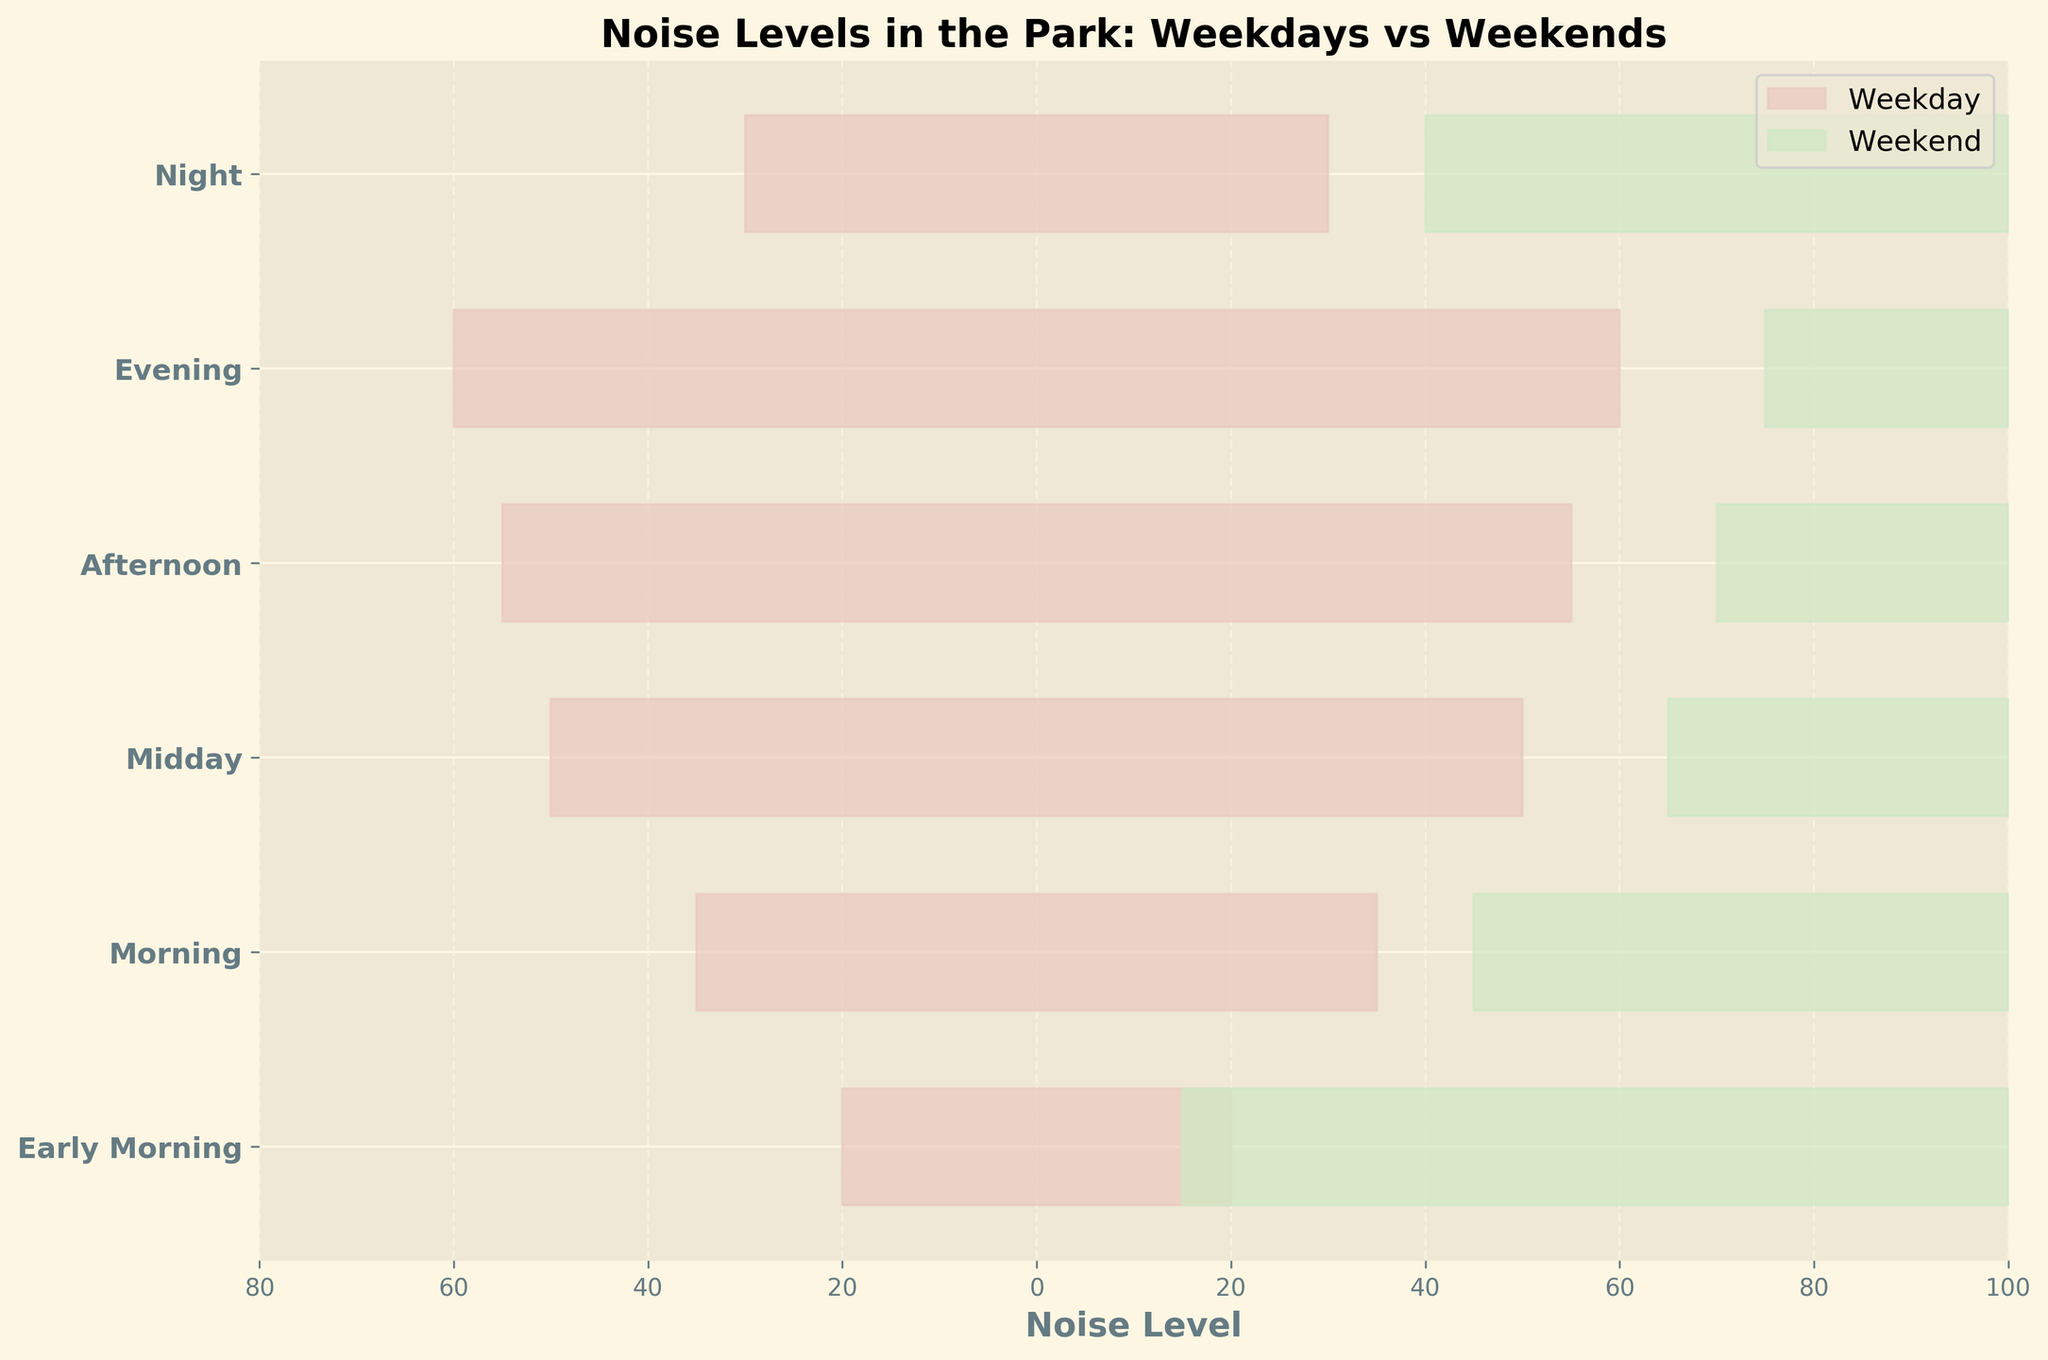How are the noise levels represented in this plot? The noise levels are visualized as filled curves. Each curve shape represents the distribution of noise levels over different times of the day, with one set of curves for weekdays and another for weekends.
Answer: Filled curves Which category has the highest noise level on weekends? By comparing the highest points of each curve representing weekends, we can see that the 'Evening' category reaches the highest peak.
Answer: Evening How do the noise levels at 6:00 compare between weekdays and weekends? The noise levels at 6:00, which are part of the 'Early Morning' category, are 20 on weekdays and 15 on weekends, indicating that weekdays are noisier in the early morning.
Answer: Weekdays are noisier Is there any time of day where noise levels are equal on both weekdays and weekends? From the plot, it appears that the curves do not intersect at the same height for any time of the day; hence, noise levels are not equal on weekdays and weekends at any time.
Answer: No Which time of day shows the greatest increase in noise levels from weekdays to weekends? By comparing the difference in heights between the weekday and weekend curves, 'Afternoon' (15:00) shows the greatest increase from 55 to 70.
Answer: Afternoon How does the noise level at 21:00 on weekends compare to its weekday counterpart? The noise levels at 21:00 show 30 for weekdays and 40 for weekends, thus weekends are noisier at night.
Answer: Weekends are noisier What can you infer about park activity between midday and evening on weekends? The noise levels increase from 65 at midday to 75 in the evening on weekends, suggesting a rise in park activity during these times.
Answer: Increase in activity On which day and at what time is the park the quietest? The 'Early Morning' category on weekends has the lowest noise level at 15, making it the quietest time in the park.
Answer: Weekend, 6:00 Which category shows a larger variation between weekdays and weekends? By examining the differences between weekday and weekend curves for each category, the 'Afternoon' category has the largest variation, increasing by 15 units.
Answer: Afternoon How consistent are noise levels throughout the day on weekdays compared to weekends? The noise levels on weekdays show a gradual increase (20 to 60) with some fluctuation, while weekends exhibit a more pronounced increase (15 to 75) and higher peaks, indicating more variability.
Answer: Weekends are more variable 